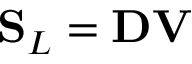<formula> <loc_0><loc_0><loc_500><loc_500>S _ { L } = D V</formula> 